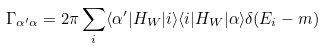Convert formula to latex. <formula><loc_0><loc_0><loc_500><loc_500>\Gamma _ { \alpha ^ { \prime } \alpha } = 2 \pi \sum _ { i } \langle \alpha ^ { \prime } | H _ { W } | i \rangle \langle i | H _ { W } | \alpha \rangle \delta ( E _ { i } - m )</formula> 